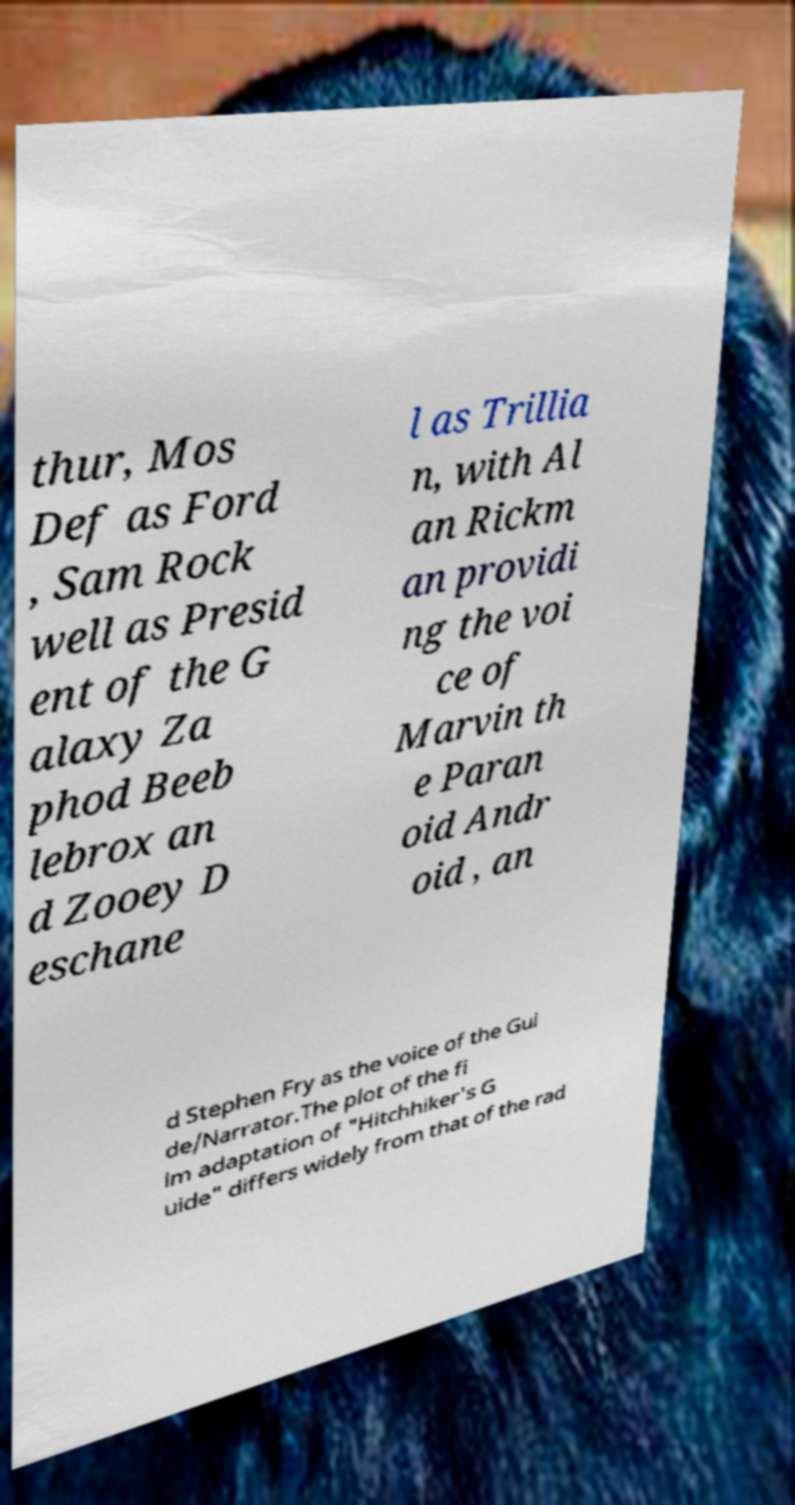Can you accurately transcribe the text from the provided image for me? thur, Mos Def as Ford , Sam Rock well as Presid ent of the G alaxy Za phod Beeb lebrox an d Zooey D eschane l as Trillia n, with Al an Rickm an providi ng the voi ce of Marvin th e Paran oid Andr oid , an d Stephen Fry as the voice of the Gui de/Narrator.The plot of the fi lm adaptation of "Hitchhiker's G uide" differs widely from that of the rad 